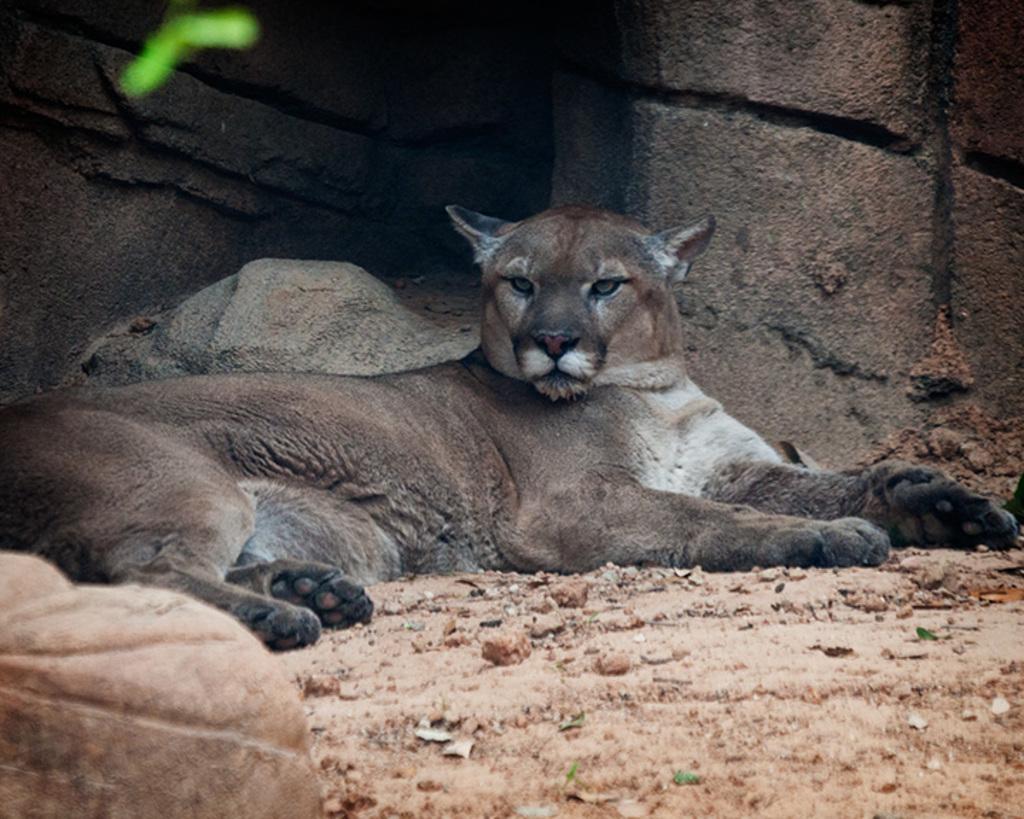Could you give a brief overview of what you see in this image? In this image I can see an animal is sleeping on the ground. On the right side it looks like a concrete wall. 